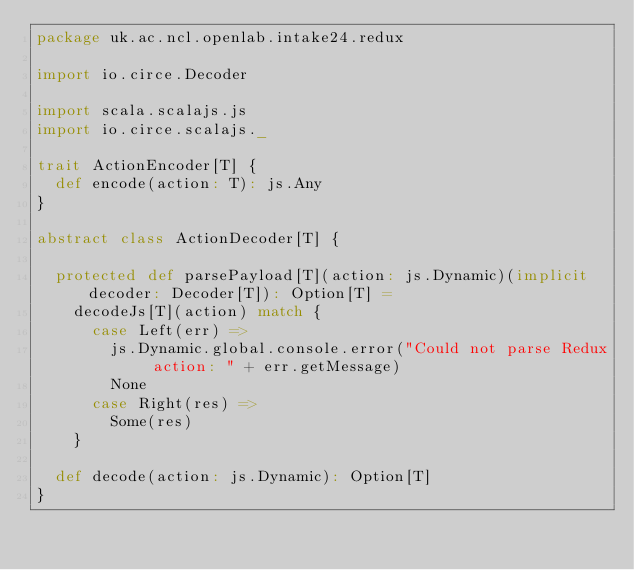Convert code to text. <code><loc_0><loc_0><loc_500><loc_500><_Scala_>package uk.ac.ncl.openlab.intake24.redux

import io.circe.Decoder

import scala.scalajs.js
import io.circe.scalajs._

trait ActionEncoder[T] {
  def encode(action: T): js.Any
}

abstract class ActionDecoder[T] {

  protected def parsePayload[T](action: js.Dynamic)(implicit decoder: Decoder[T]): Option[T] =
    decodeJs[T](action) match {
      case Left(err) =>
        js.Dynamic.global.console.error("Could not parse Redux action: " + err.getMessage)
        None
      case Right(res) =>
        Some(res)
    }

  def decode(action: js.Dynamic): Option[T]
}
</code> 